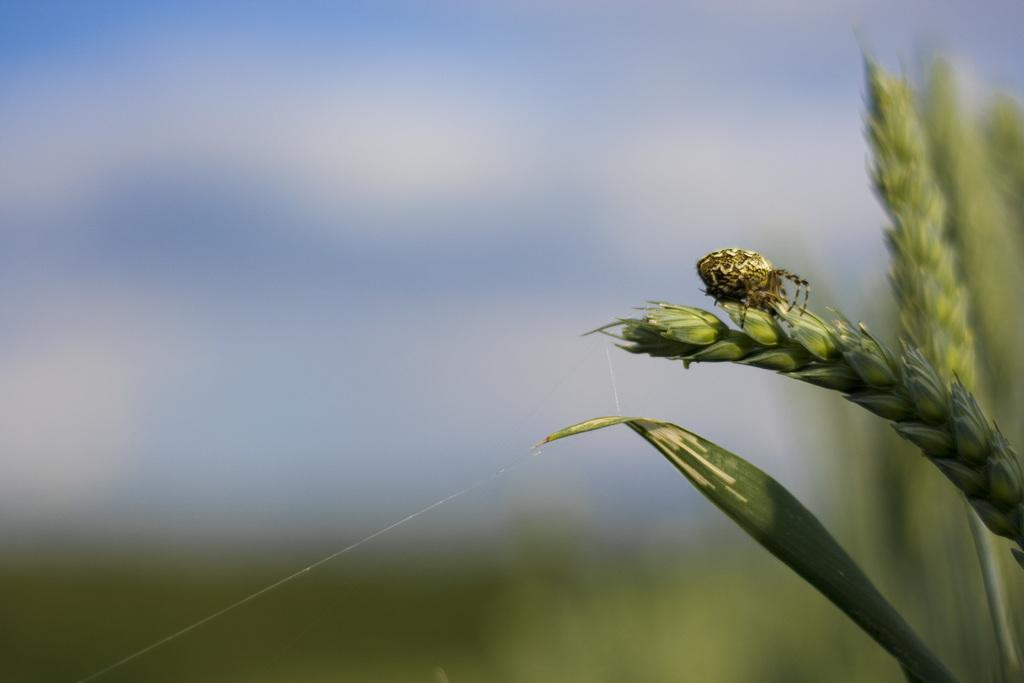What type of living organisms can be seen in the image? Plants can be seen in the image. What other creature is present in the image? There is a bug in the image. Can you describe the background of the image? The background of the image is blurry. What type of cord is being used to hang the shirt in the image? There is no mention of a cord or a shirt in the image; it only mentions plants and a bug. 